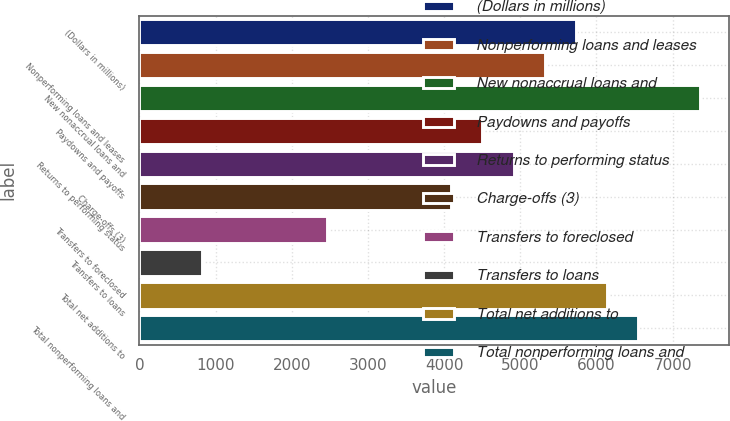Convert chart. <chart><loc_0><loc_0><loc_500><loc_500><bar_chart><fcel>(Dollars in millions)<fcel>Nonperforming loans and leases<fcel>New nonaccrual loans and<fcel>Paydowns and payoffs<fcel>Returns to performing status<fcel>Charge-offs (3)<fcel>Transfers to foreclosed<fcel>Transfers to loans<fcel>Total net additions to<fcel>Total nonperforming loans and<nl><fcel>5729.98<fcel>5320.74<fcel>7366.94<fcel>4502.26<fcel>4911.5<fcel>4093.02<fcel>2456.06<fcel>819.1<fcel>6139.22<fcel>6548.46<nl></chart> 